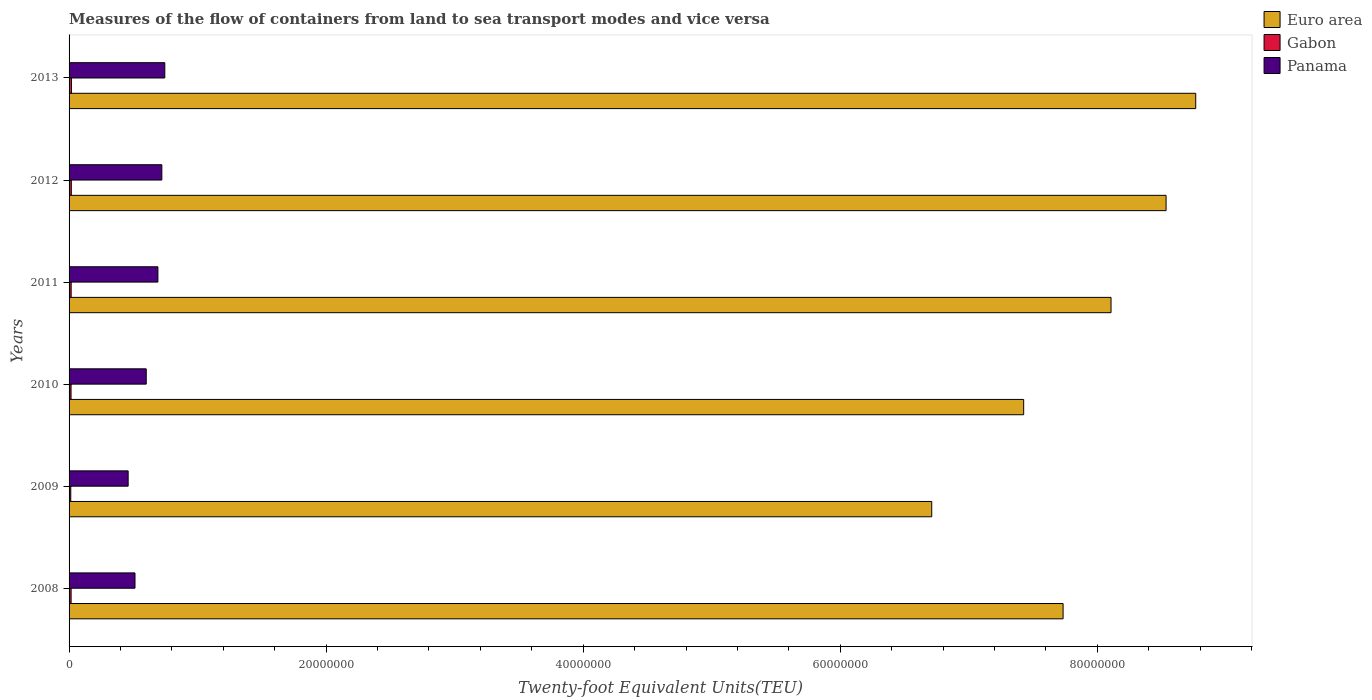How many different coloured bars are there?
Your answer should be compact. 3. How many groups of bars are there?
Provide a short and direct response. 6. Are the number of bars on each tick of the Y-axis equal?
Give a very brief answer. Yes. How many bars are there on the 2nd tick from the top?
Give a very brief answer. 3. How many bars are there on the 5th tick from the bottom?
Offer a very short reply. 3. What is the container port traffic in Gabon in 2008?
Offer a very short reply. 1.59e+05. Across all years, what is the maximum container port traffic in Euro area?
Offer a very short reply. 8.77e+07. Across all years, what is the minimum container port traffic in Euro area?
Provide a succinct answer. 6.71e+07. What is the total container port traffic in Panama in the graph?
Offer a terse response. 3.73e+07. What is the difference between the container port traffic in Panama in 2009 and that in 2011?
Offer a very short reply. -2.31e+06. What is the difference between the container port traffic in Gabon in 2013 and the container port traffic in Euro area in 2012?
Your response must be concise. -8.52e+07. What is the average container port traffic in Euro area per year?
Your answer should be very brief. 7.88e+07. In the year 2011, what is the difference between the container port traffic in Panama and container port traffic in Gabon?
Offer a very short reply. 6.75e+06. What is the ratio of the container port traffic in Gabon in 2009 to that in 2012?
Your response must be concise. 0.76. Is the container port traffic in Panama in 2008 less than that in 2012?
Your answer should be very brief. Yes. What is the difference between the highest and the second highest container port traffic in Panama?
Your response must be concise. 2.30e+05. What is the difference between the highest and the lowest container port traffic in Panama?
Ensure brevity in your answer.  2.85e+06. What does the 1st bar from the top in 2009 represents?
Make the answer very short. Panama. Is it the case that in every year, the sum of the container port traffic in Panama and container port traffic in Euro area is greater than the container port traffic in Gabon?
Offer a terse response. Yes. Are all the bars in the graph horizontal?
Your answer should be very brief. Yes. Does the graph contain any zero values?
Offer a terse response. No. Does the graph contain grids?
Your answer should be compact. No. How are the legend labels stacked?
Your answer should be very brief. Vertical. What is the title of the graph?
Provide a succinct answer. Measures of the flow of containers from land to sea transport modes and vice versa. Does "China" appear as one of the legend labels in the graph?
Provide a succinct answer. No. What is the label or title of the X-axis?
Offer a terse response. Twenty-foot Equivalent Units(TEU). What is the Twenty-foot Equivalent Units(TEU) in Euro area in 2008?
Give a very brief answer. 7.73e+07. What is the Twenty-foot Equivalent Units(TEU) of Gabon in 2008?
Your response must be concise. 1.59e+05. What is the Twenty-foot Equivalent Units(TEU) of Panama in 2008?
Ensure brevity in your answer.  5.13e+06. What is the Twenty-foot Equivalent Units(TEU) in Euro area in 2009?
Make the answer very short. 6.71e+07. What is the Twenty-foot Equivalent Units(TEU) in Gabon in 2009?
Provide a succinct answer. 1.32e+05. What is the Twenty-foot Equivalent Units(TEU) of Panama in 2009?
Offer a very short reply. 4.60e+06. What is the Twenty-foot Equivalent Units(TEU) in Euro area in 2010?
Your answer should be compact. 7.43e+07. What is the Twenty-foot Equivalent Units(TEU) of Gabon in 2010?
Make the answer very short. 1.54e+05. What is the Twenty-foot Equivalent Units(TEU) in Panama in 2010?
Offer a very short reply. 6.00e+06. What is the Twenty-foot Equivalent Units(TEU) of Euro area in 2011?
Your answer should be very brief. 8.11e+07. What is the Twenty-foot Equivalent Units(TEU) of Gabon in 2011?
Your response must be concise. 1.62e+05. What is the Twenty-foot Equivalent Units(TEU) in Panama in 2011?
Your response must be concise. 6.91e+06. What is the Twenty-foot Equivalent Units(TEU) in Euro area in 2012?
Provide a succinct answer. 8.53e+07. What is the Twenty-foot Equivalent Units(TEU) of Gabon in 2012?
Give a very brief answer. 1.75e+05. What is the Twenty-foot Equivalent Units(TEU) in Panama in 2012?
Offer a very short reply. 7.22e+06. What is the Twenty-foot Equivalent Units(TEU) of Euro area in 2013?
Your response must be concise. 8.77e+07. What is the Twenty-foot Equivalent Units(TEU) in Gabon in 2013?
Provide a short and direct response. 1.88e+05. What is the Twenty-foot Equivalent Units(TEU) in Panama in 2013?
Your answer should be very brief. 7.45e+06. Across all years, what is the maximum Twenty-foot Equivalent Units(TEU) in Euro area?
Ensure brevity in your answer.  8.77e+07. Across all years, what is the maximum Twenty-foot Equivalent Units(TEU) of Gabon?
Your answer should be very brief. 1.88e+05. Across all years, what is the maximum Twenty-foot Equivalent Units(TEU) in Panama?
Your response must be concise. 7.45e+06. Across all years, what is the minimum Twenty-foot Equivalent Units(TEU) in Euro area?
Your response must be concise. 6.71e+07. Across all years, what is the minimum Twenty-foot Equivalent Units(TEU) in Gabon?
Provide a succinct answer. 1.32e+05. Across all years, what is the minimum Twenty-foot Equivalent Units(TEU) in Panama?
Your answer should be compact. 4.60e+06. What is the total Twenty-foot Equivalent Units(TEU) in Euro area in the graph?
Provide a short and direct response. 4.73e+08. What is the total Twenty-foot Equivalent Units(TEU) in Gabon in the graph?
Make the answer very short. 9.70e+05. What is the total Twenty-foot Equivalent Units(TEU) of Panama in the graph?
Your response must be concise. 3.73e+07. What is the difference between the Twenty-foot Equivalent Units(TEU) of Euro area in 2008 and that in 2009?
Your answer should be compact. 1.02e+07. What is the difference between the Twenty-foot Equivalent Units(TEU) in Gabon in 2008 and that in 2009?
Keep it short and to the point. 2.65e+04. What is the difference between the Twenty-foot Equivalent Units(TEU) of Panama in 2008 and that in 2009?
Offer a terse response. 5.32e+05. What is the difference between the Twenty-foot Equivalent Units(TEU) in Euro area in 2008 and that in 2010?
Provide a succinct answer. 3.07e+06. What is the difference between the Twenty-foot Equivalent Units(TEU) in Gabon in 2008 and that in 2010?
Ensure brevity in your answer.  5227.04. What is the difference between the Twenty-foot Equivalent Units(TEU) in Panama in 2008 and that in 2010?
Ensure brevity in your answer.  -8.74e+05. What is the difference between the Twenty-foot Equivalent Units(TEU) of Euro area in 2008 and that in 2011?
Your response must be concise. -3.73e+06. What is the difference between the Twenty-foot Equivalent Units(TEU) in Gabon in 2008 and that in 2011?
Provide a succinct answer. -3531.4. What is the difference between the Twenty-foot Equivalent Units(TEU) of Panama in 2008 and that in 2011?
Offer a terse response. -1.78e+06. What is the difference between the Twenty-foot Equivalent Units(TEU) of Euro area in 2008 and that in 2012?
Your answer should be very brief. -8.01e+06. What is the difference between the Twenty-foot Equivalent Units(TEU) in Gabon in 2008 and that in 2012?
Give a very brief answer. -1.57e+04. What is the difference between the Twenty-foot Equivalent Units(TEU) in Panama in 2008 and that in 2012?
Your answer should be very brief. -2.09e+06. What is the difference between the Twenty-foot Equivalent Units(TEU) in Euro area in 2008 and that in 2013?
Provide a succinct answer. -1.03e+07. What is the difference between the Twenty-foot Equivalent Units(TEU) of Gabon in 2008 and that in 2013?
Ensure brevity in your answer.  -2.95e+04. What is the difference between the Twenty-foot Equivalent Units(TEU) of Panama in 2008 and that in 2013?
Your response must be concise. -2.32e+06. What is the difference between the Twenty-foot Equivalent Units(TEU) of Euro area in 2009 and that in 2010?
Your response must be concise. -7.15e+06. What is the difference between the Twenty-foot Equivalent Units(TEU) in Gabon in 2009 and that in 2010?
Provide a short and direct response. -2.13e+04. What is the difference between the Twenty-foot Equivalent Units(TEU) in Panama in 2009 and that in 2010?
Keep it short and to the point. -1.41e+06. What is the difference between the Twenty-foot Equivalent Units(TEU) in Euro area in 2009 and that in 2011?
Offer a terse response. -1.39e+07. What is the difference between the Twenty-foot Equivalent Units(TEU) of Gabon in 2009 and that in 2011?
Offer a terse response. -3.01e+04. What is the difference between the Twenty-foot Equivalent Units(TEU) in Panama in 2009 and that in 2011?
Give a very brief answer. -2.31e+06. What is the difference between the Twenty-foot Equivalent Units(TEU) of Euro area in 2009 and that in 2012?
Offer a very short reply. -1.82e+07. What is the difference between the Twenty-foot Equivalent Units(TEU) of Gabon in 2009 and that in 2012?
Provide a succinct answer. -4.22e+04. What is the difference between the Twenty-foot Equivalent Units(TEU) of Panama in 2009 and that in 2012?
Provide a short and direct response. -2.62e+06. What is the difference between the Twenty-foot Equivalent Units(TEU) of Euro area in 2009 and that in 2013?
Keep it short and to the point. -2.05e+07. What is the difference between the Twenty-foot Equivalent Units(TEU) of Gabon in 2009 and that in 2013?
Offer a terse response. -5.60e+04. What is the difference between the Twenty-foot Equivalent Units(TEU) in Panama in 2009 and that in 2013?
Your answer should be compact. -2.85e+06. What is the difference between the Twenty-foot Equivalent Units(TEU) in Euro area in 2010 and that in 2011?
Give a very brief answer. -6.80e+06. What is the difference between the Twenty-foot Equivalent Units(TEU) of Gabon in 2010 and that in 2011?
Offer a terse response. -8758.45. What is the difference between the Twenty-foot Equivalent Units(TEU) in Panama in 2010 and that in 2011?
Your answer should be very brief. -9.08e+05. What is the difference between the Twenty-foot Equivalent Units(TEU) of Euro area in 2010 and that in 2012?
Your answer should be very brief. -1.11e+07. What is the difference between the Twenty-foot Equivalent Units(TEU) of Gabon in 2010 and that in 2012?
Your answer should be compact. -2.09e+04. What is the difference between the Twenty-foot Equivalent Units(TEU) in Panama in 2010 and that in 2012?
Your answer should be very brief. -1.21e+06. What is the difference between the Twenty-foot Equivalent Units(TEU) of Euro area in 2010 and that in 2013?
Offer a terse response. -1.34e+07. What is the difference between the Twenty-foot Equivalent Units(TEU) of Gabon in 2010 and that in 2013?
Make the answer very short. -3.47e+04. What is the difference between the Twenty-foot Equivalent Units(TEU) in Panama in 2010 and that in 2013?
Your answer should be compact. -1.44e+06. What is the difference between the Twenty-foot Equivalent Units(TEU) of Euro area in 2011 and that in 2012?
Give a very brief answer. -4.28e+06. What is the difference between the Twenty-foot Equivalent Units(TEU) in Gabon in 2011 and that in 2012?
Provide a succinct answer. -1.22e+04. What is the difference between the Twenty-foot Equivalent Units(TEU) in Panama in 2011 and that in 2012?
Provide a succinct answer. -3.06e+05. What is the difference between the Twenty-foot Equivalent Units(TEU) in Euro area in 2011 and that in 2013?
Offer a terse response. -6.59e+06. What is the difference between the Twenty-foot Equivalent Units(TEU) in Gabon in 2011 and that in 2013?
Make the answer very short. -2.60e+04. What is the difference between the Twenty-foot Equivalent Units(TEU) in Panama in 2011 and that in 2013?
Keep it short and to the point. -5.36e+05. What is the difference between the Twenty-foot Equivalent Units(TEU) of Euro area in 2012 and that in 2013?
Your answer should be compact. -2.31e+06. What is the difference between the Twenty-foot Equivalent Units(TEU) in Gabon in 2012 and that in 2013?
Keep it short and to the point. -1.38e+04. What is the difference between the Twenty-foot Equivalent Units(TEU) of Panama in 2012 and that in 2013?
Ensure brevity in your answer.  -2.30e+05. What is the difference between the Twenty-foot Equivalent Units(TEU) in Euro area in 2008 and the Twenty-foot Equivalent Units(TEU) in Gabon in 2009?
Your response must be concise. 7.72e+07. What is the difference between the Twenty-foot Equivalent Units(TEU) in Euro area in 2008 and the Twenty-foot Equivalent Units(TEU) in Panama in 2009?
Give a very brief answer. 7.27e+07. What is the difference between the Twenty-foot Equivalent Units(TEU) in Gabon in 2008 and the Twenty-foot Equivalent Units(TEU) in Panama in 2009?
Provide a short and direct response. -4.44e+06. What is the difference between the Twenty-foot Equivalent Units(TEU) of Euro area in 2008 and the Twenty-foot Equivalent Units(TEU) of Gabon in 2010?
Your answer should be very brief. 7.72e+07. What is the difference between the Twenty-foot Equivalent Units(TEU) of Euro area in 2008 and the Twenty-foot Equivalent Units(TEU) of Panama in 2010?
Make the answer very short. 7.13e+07. What is the difference between the Twenty-foot Equivalent Units(TEU) in Gabon in 2008 and the Twenty-foot Equivalent Units(TEU) in Panama in 2010?
Your answer should be very brief. -5.84e+06. What is the difference between the Twenty-foot Equivalent Units(TEU) of Euro area in 2008 and the Twenty-foot Equivalent Units(TEU) of Gabon in 2011?
Provide a succinct answer. 7.72e+07. What is the difference between the Twenty-foot Equivalent Units(TEU) in Euro area in 2008 and the Twenty-foot Equivalent Units(TEU) in Panama in 2011?
Your answer should be compact. 7.04e+07. What is the difference between the Twenty-foot Equivalent Units(TEU) of Gabon in 2008 and the Twenty-foot Equivalent Units(TEU) of Panama in 2011?
Give a very brief answer. -6.75e+06. What is the difference between the Twenty-foot Equivalent Units(TEU) in Euro area in 2008 and the Twenty-foot Equivalent Units(TEU) in Gabon in 2012?
Offer a terse response. 7.72e+07. What is the difference between the Twenty-foot Equivalent Units(TEU) in Euro area in 2008 and the Twenty-foot Equivalent Units(TEU) in Panama in 2012?
Make the answer very short. 7.01e+07. What is the difference between the Twenty-foot Equivalent Units(TEU) in Gabon in 2008 and the Twenty-foot Equivalent Units(TEU) in Panama in 2012?
Your answer should be very brief. -7.06e+06. What is the difference between the Twenty-foot Equivalent Units(TEU) of Euro area in 2008 and the Twenty-foot Equivalent Units(TEU) of Gabon in 2013?
Offer a very short reply. 7.71e+07. What is the difference between the Twenty-foot Equivalent Units(TEU) of Euro area in 2008 and the Twenty-foot Equivalent Units(TEU) of Panama in 2013?
Provide a succinct answer. 6.99e+07. What is the difference between the Twenty-foot Equivalent Units(TEU) of Gabon in 2008 and the Twenty-foot Equivalent Units(TEU) of Panama in 2013?
Make the answer very short. -7.29e+06. What is the difference between the Twenty-foot Equivalent Units(TEU) of Euro area in 2009 and the Twenty-foot Equivalent Units(TEU) of Gabon in 2010?
Make the answer very short. 6.70e+07. What is the difference between the Twenty-foot Equivalent Units(TEU) in Euro area in 2009 and the Twenty-foot Equivalent Units(TEU) in Panama in 2010?
Provide a succinct answer. 6.11e+07. What is the difference between the Twenty-foot Equivalent Units(TEU) of Gabon in 2009 and the Twenty-foot Equivalent Units(TEU) of Panama in 2010?
Give a very brief answer. -5.87e+06. What is the difference between the Twenty-foot Equivalent Units(TEU) in Euro area in 2009 and the Twenty-foot Equivalent Units(TEU) in Gabon in 2011?
Provide a short and direct response. 6.70e+07. What is the difference between the Twenty-foot Equivalent Units(TEU) in Euro area in 2009 and the Twenty-foot Equivalent Units(TEU) in Panama in 2011?
Your answer should be very brief. 6.02e+07. What is the difference between the Twenty-foot Equivalent Units(TEU) of Gabon in 2009 and the Twenty-foot Equivalent Units(TEU) of Panama in 2011?
Offer a terse response. -6.78e+06. What is the difference between the Twenty-foot Equivalent Units(TEU) in Euro area in 2009 and the Twenty-foot Equivalent Units(TEU) in Gabon in 2012?
Make the answer very short. 6.69e+07. What is the difference between the Twenty-foot Equivalent Units(TEU) of Euro area in 2009 and the Twenty-foot Equivalent Units(TEU) of Panama in 2012?
Offer a very short reply. 5.99e+07. What is the difference between the Twenty-foot Equivalent Units(TEU) of Gabon in 2009 and the Twenty-foot Equivalent Units(TEU) of Panama in 2012?
Provide a succinct answer. -7.09e+06. What is the difference between the Twenty-foot Equivalent Units(TEU) in Euro area in 2009 and the Twenty-foot Equivalent Units(TEU) in Gabon in 2013?
Make the answer very short. 6.69e+07. What is the difference between the Twenty-foot Equivalent Units(TEU) of Euro area in 2009 and the Twenty-foot Equivalent Units(TEU) of Panama in 2013?
Ensure brevity in your answer.  5.97e+07. What is the difference between the Twenty-foot Equivalent Units(TEU) of Gabon in 2009 and the Twenty-foot Equivalent Units(TEU) of Panama in 2013?
Your answer should be very brief. -7.32e+06. What is the difference between the Twenty-foot Equivalent Units(TEU) in Euro area in 2010 and the Twenty-foot Equivalent Units(TEU) in Gabon in 2011?
Your answer should be very brief. 7.41e+07. What is the difference between the Twenty-foot Equivalent Units(TEU) in Euro area in 2010 and the Twenty-foot Equivalent Units(TEU) in Panama in 2011?
Provide a short and direct response. 6.74e+07. What is the difference between the Twenty-foot Equivalent Units(TEU) of Gabon in 2010 and the Twenty-foot Equivalent Units(TEU) of Panama in 2011?
Give a very brief answer. -6.76e+06. What is the difference between the Twenty-foot Equivalent Units(TEU) in Euro area in 2010 and the Twenty-foot Equivalent Units(TEU) in Gabon in 2012?
Provide a short and direct response. 7.41e+07. What is the difference between the Twenty-foot Equivalent Units(TEU) in Euro area in 2010 and the Twenty-foot Equivalent Units(TEU) in Panama in 2012?
Ensure brevity in your answer.  6.71e+07. What is the difference between the Twenty-foot Equivalent Units(TEU) in Gabon in 2010 and the Twenty-foot Equivalent Units(TEU) in Panama in 2012?
Your response must be concise. -7.06e+06. What is the difference between the Twenty-foot Equivalent Units(TEU) of Euro area in 2010 and the Twenty-foot Equivalent Units(TEU) of Gabon in 2013?
Your answer should be compact. 7.41e+07. What is the difference between the Twenty-foot Equivalent Units(TEU) in Euro area in 2010 and the Twenty-foot Equivalent Units(TEU) in Panama in 2013?
Your answer should be compact. 6.68e+07. What is the difference between the Twenty-foot Equivalent Units(TEU) in Gabon in 2010 and the Twenty-foot Equivalent Units(TEU) in Panama in 2013?
Provide a short and direct response. -7.29e+06. What is the difference between the Twenty-foot Equivalent Units(TEU) of Euro area in 2011 and the Twenty-foot Equivalent Units(TEU) of Gabon in 2012?
Make the answer very short. 8.09e+07. What is the difference between the Twenty-foot Equivalent Units(TEU) of Euro area in 2011 and the Twenty-foot Equivalent Units(TEU) of Panama in 2012?
Ensure brevity in your answer.  7.38e+07. What is the difference between the Twenty-foot Equivalent Units(TEU) in Gabon in 2011 and the Twenty-foot Equivalent Units(TEU) in Panama in 2012?
Keep it short and to the point. -7.06e+06. What is the difference between the Twenty-foot Equivalent Units(TEU) of Euro area in 2011 and the Twenty-foot Equivalent Units(TEU) of Gabon in 2013?
Your answer should be very brief. 8.09e+07. What is the difference between the Twenty-foot Equivalent Units(TEU) of Euro area in 2011 and the Twenty-foot Equivalent Units(TEU) of Panama in 2013?
Keep it short and to the point. 7.36e+07. What is the difference between the Twenty-foot Equivalent Units(TEU) in Gabon in 2011 and the Twenty-foot Equivalent Units(TEU) in Panama in 2013?
Give a very brief answer. -7.29e+06. What is the difference between the Twenty-foot Equivalent Units(TEU) of Euro area in 2012 and the Twenty-foot Equivalent Units(TEU) of Gabon in 2013?
Make the answer very short. 8.52e+07. What is the difference between the Twenty-foot Equivalent Units(TEU) of Euro area in 2012 and the Twenty-foot Equivalent Units(TEU) of Panama in 2013?
Provide a succinct answer. 7.79e+07. What is the difference between the Twenty-foot Equivalent Units(TEU) of Gabon in 2012 and the Twenty-foot Equivalent Units(TEU) of Panama in 2013?
Make the answer very short. -7.27e+06. What is the average Twenty-foot Equivalent Units(TEU) of Euro area per year?
Offer a terse response. 7.88e+07. What is the average Twenty-foot Equivalent Units(TEU) of Gabon per year?
Your response must be concise. 1.62e+05. What is the average Twenty-foot Equivalent Units(TEU) in Panama per year?
Provide a short and direct response. 6.22e+06. In the year 2008, what is the difference between the Twenty-foot Equivalent Units(TEU) of Euro area and Twenty-foot Equivalent Units(TEU) of Gabon?
Provide a short and direct response. 7.72e+07. In the year 2008, what is the difference between the Twenty-foot Equivalent Units(TEU) of Euro area and Twenty-foot Equivalent Units(TEU) of Panama?
Make the answer very short. 7.22e+07. In the year 2008, what is the difference between the Twenty-foot Equivalent Units(TEU) of Gabon and Twenty-foot Equivalent Units(TEU) of Panama?
Give a very brief answer. -4.97e+06. In the year 2009, what is the difference between the Twenty-foot Equivalent Units(TEU) in Euro area and Twenty-foot Equivalent Units(TEU) in Gabon?
Offer a very short reply. 6.70e+07. In the year 2009, what is the difference between the Twenty-foot Equivalent Units(TEU) in Euro area and Twenty-foot Equivalent Units(TEU) in Panama?
Keep it short and to the point. 6.25e+07. In the year 2009, what is the difference between the Twenty-foot Equivalent Units(TEU) of Gabon and Twenty-foot Equivalent Units(TEU) of Panama?
Offer a very short reply. -4.46e+06. In the year 2010, what is the difference between the Twenty-foot Equivalent Units(TEU) in Euro area and Twenty-foot Equivalent Units(TEU) in Gabon?
Your answer should be very brief. 7.41e+07. In the year 2010, what is the difference between the Twenty-foot Equivalent Units(TEU) of Euro area and Twenty-foot Equivalent Units(TEU) of Panama?
Provide a short and direct response. 6.83e+07. In the year 2010, what is the difference between the Twenty-foot Equivalent Units(TEU) of Gabon and Twenty-foot Equivalent Units(TEU) of Panama?
Make the answer very short. -5.85e+06. In the year 2011, what is the difference between the Twenty-foot Equivalent Units(TEU) in Euro area and Twenty-foot Equivalent Units(TEU) in Gabon?
Offer a terse response. 8.09e+07. In the year 2011, what is the difference between the Twenty-foot Equivalent Units(TEU) in Euro area and Twenty-foot Equivalent Units(TEU) in Panama?
Keep it short and to the point. 7.42e+07. In the year 2011, what is the difference between the Twenty-foot Equivalent Units(TEU) of Gabon and Twenty-foot Equivalent Units(TEU) of Panama?
Your response must be concise. -6.75e+06. In the year 2012, what is the difference between the Twenty-foot Equivalent Units(TEU) in Euro area and Twenty-foot Equivalent Units(TEU) in Gabon?
Keep it short and to the point. 8.52e+07. In the year 2012, what is the difference between the Twenty-foot Equivalent Units(TEU) of Euro area and Twenty-foot Equivalent Units(TEU) of Panama?
Make the answer very short. 7.81e+07. In the year 2012, what is the difference between the Twenty-foot Equivalent Units(TEU) of Gabon and Twenty-foot Equivalent Units(TEU) of Panama?
Offer a terse response. -7.04e+06. In the year 2013, what is the difference between the Twenty-foot Equivalent Units(TEU) of Euro area and Twenty-foot Equivalent Units(TEU) of Gabon?
Keep it short and to the point. 8.75e+07. In the year 2013, what is the difference between the Twenty-foot Equivalent Units(TEU) of Euro area and Twenty-foot Equivalent Units(TEU) of Panama?
Ensure brevity in your answer.  8.02e+07. In the year 2013, what is the difference between the Twenty-foot Equivalent Units(TEU) of Gabon and Twenty-foot Equivalent Units(TEU) of Panama?
Your response must be concise. -7.26e+06. What is the ratio of the Twenty-foot Equivalent Units(TEU) of Euro area in 2008 to that in 2009?
Give a very brief answer. 1.15. What is the ratio of the Twenty-foot Equivalent Units(TEU) in Gabon in 2008 to that in 2009?
Provide a short and direct response. 1.2. What is the ratio of the Twenty-foot Equivalent Units(TEU) in Panama in 2008 to that in 2009?
Ensure brevity in your answer.  1.12. What is the ratio of the Twenty-foot Equivalent Units(TEU) of Euro area in 2008 to that in 2010?
Give a very brief answer. 1.04. What is the ratio of the Twenty-foot Equivalent Units(TEU) in Gabon in 2008 to that in 2010?
Provide a succinct answer. 1.03. What is the ratio of the Twenty-foot Equivalent Units(TEU) in Panama in 2008 to that in 2010?
Offer a terse response. 0.85. What is the ratio of the Twenty-foot Equivalent Units(TEU) of Euro area in 2008 to that in 2011?
Your answer should be very brief. 0.95. What is the ratio of the Twenty-foot Equivalent Units(TEU) of Gabon in 2008 to that in 2011?
Provide a succinct answer. 0.98. What is the ratio of the Twenty-foot Equivalent Units(TEU) in Panama in 2008 to that in 2011?
Your answer should be very brief. 0.74. What is the ratio of the Twenty-foot Equivalent Units(TEU) of Euro area in 2008 to that in 2012?
Your answer should be compact. 0.91. What is the ratio of the Twenty-foot Equivalent Units(TEU) in Gabon in 2008 to that in 2012?
Provide a succinct answer. 0.91. What is the ratio of the Twenty-foot Equivalent Units(TEU) of Panama in 2008 to that in 2012?
Give a very brief answer. 0.71. What is the ratio of the Twenty-foot Equivalent Units(TEU) of Euro area in 2008 to that in 2013?
Give a very brief answer. 0.88. What is the ratio of the Twenty-foot Equivalent Units(TEU) of Gabon in 2008 to that in 2013?
Your response must be concise. 0.84. What is the ratio of the Twenty-foot Equivalent Units(TEU) in Panama in 2008 to that in 2013?
Give a very brief answer. 0.69. What is the ratio of the Twenty-foot Equivalent Units(TEU) of Euro area in 2009 to that in 2010?
Offer a terse response. 0.9. What is the ratio of the Twenty-foot Equivalent Units(TEU) in Gabon in 2009 to that in 2010?
Your answer should be very brief. 0.86. What is the ratio of the Twenty-foot Equivalent Units(TEU) of Panama in 2009 to that in 2010?
Your answer should be compact. 0.77. What is the ratio of the Twenty-foot Equivalent Units(TEU) in Euro area in 2009 to that in 2011?
Give a very brief answer. 0.83. What is the ratio of the Twenty-foot Equivalent Units(TEU) in Gabon in 2009 to that in 2011?
Ensure brevity in your answer.  0.81. What is the ratio of the Twenty-foot Equivalent Units(TEU) in Panama in 2009 to that in 2011?
Offer a very short reply. 0.67. What is the ratio of the Twenty-foot Equivalent Units(TEU) in Euro area in 2009 to that in 2012?
Make the answer very short. 0.79. What is the ratio of the Twenty-foot Equivalent Units(TEU) of Gabon in 2009 to that in 2012?
Ensure brevity in your answer.  0.76. What is the ratio of the Twenty-foot Equivalent Units(TEU) of Panama in 2009 to that in 2012?
Ensure brevity in your answer.  0.64. What is the ratio of the Twenty-foot Equivalent Units(TEU) of Euro area in 2009 to that in 2013?
Provide a short and direct response. 0.77. What is the ratio of the Twenty-foot Equivalent Units(TEU) in Gabon in 2009 to that in 2013?
Provide a succinct answer. 0.7. What is the ratio of the Twenty-foot Equivalent Units(TEU) in Panama in 2009 to that in 2013?
Your response must be concise. 0.62. What is the ratio of the Twenty-foot Equivalent Units(TEU) of Euro area in 2010 to that in 2011?
Offer a very short reply. 0.92. What is the ratio of the Twenty-foot Equivalent Units(TEU) in Gabon in 2010 to that in 2011?
Offer a very short reply. 0.95. What is the ratio of the Twenty-foot Equivalent Units(TEU) of Panama in 2010 to that in 2011?
Give a very brief answer. 0.87. What is the ratio of the Twenty-foot Equivalent Units(TEU) in Euro area in 2010 to that in 2012?
Offer a very short reply. 0.87. What is the ratio of the Twenty-foot Equivalent Units(TEU) of Gabon in 2010 to that in 2012?
Offer a very short reply. 0.88. What is the ratio of the Twenty-foot Equivalent Units(TEU) of Panama in 2010 to that in 2012?
Provide a short and direct response. 0.83. What is the ratio of the Twenty-foot Equivalent Units(TEU) of Euro area in 2010 to that in 2013?
Your response must be concise. 0.85. What is the ratio of the Twenty-foot Equivalent Units(TEU) in Gabon in 2010 to that in 2013?
Your answer should be compact. 0.82. What is the ratio of the Twenty-foot Equivalent Units(TEU) of Panama in 2010 to that in 2013?
Give a very brief answer. 0.81. What is the ratio of the Twenty-foot Equivalent Units(TEU) of Euro area in 2011 to that in 2012?
Make the answer very short. 0.95. What is the ratio of the Twenty-foot Equivalent Units(TEU) in Gabon in 2011 to that in 2012?
Provide a short and direct response. 0.93. What is the ratio of the Twenty-foot Equivalent Units(TEU) of Panama in 2011 to that in 2012?
Provide a succinct answer. 0.96. What is the ratio of the Twenty-foot Equivalent Units(TEU) in Euro area in 2011 to that in 2013?
Give a very brief answer. 0.92. What is the ratio of the Twenty-foot Equivalent Units(TEU) of Gabon in 2011 to that in 2013?
Provide a short and direct response. 0.86. What is the ratio of the Twenty-foot Equivalent Units(TEU) of Panama in 2011 to that in 2013?
Your response must be concise. 0.93. What is the ratio of the Twenty-foot Equivalent Units(TEU) in Euro area in 2012 to that in 2013?
Provide a short and direct response. 0.97. What is the ratio of the Twenty-foot Equivalent Units(TEU) of Gabon in 2012 to that in 2013?
Offer a very short reply. 0.93. What is the ratio of the Twenty-foot Equivalent Units(TEU) in Panama in 2012 to that in 2013?
Offer a very short reply. 0.97. What is the difference between the highest and the second highest Twenty-foot Equivalent Units(TEU) in Euro area?
Your answer should be compact. 2.31e+06. What is the difference between the highest and the second highest Twenty-foot Equivalent Units(TEU) of Gabon?
Give a very brief answer. 1.38e+04. What is the difference between the highest and the second highest Twenty-foot Equivalent Units(TEU) in Panama?
Offer a very short reply. 2.30e+05. What is the difference between the highest and the lowest Twenty-foot Equivalent Units(TEU) of Euro area?
Offer a very short reply. 2.05e+07. What is the difference between the highest and the lowest Twenty-foot Equivalent Units(TEU) in Gabon?
Your answer should be compact. 5.60e+04. What is the difference between the highest and the lowest Twenty-foot Equivalent Units(TEU) of Panama?
Your answer should be very brief. 2.85e+06. 